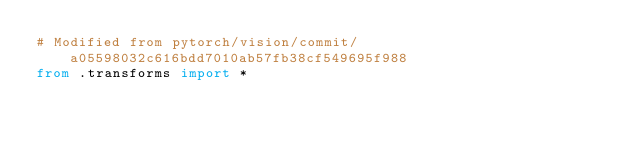Convert code to text. <code><loc_0><loc_0><loc_500><loc_500><_Python_># Modified from pytorch/vision/commit/a05598032c616bdd7010ab57fb38cf549695f988
from .transforms import *
</code> 